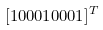<formula> <loc_0><loc_0><loc_500><loc_500>[ 1 0 0 0 1 0 0 0 1 ] ^ { T }</formula> 